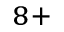Convert formula to latex. <formula><loc_0><loc_0><loc_500><loc_500>^ { 8 + }</formula> 